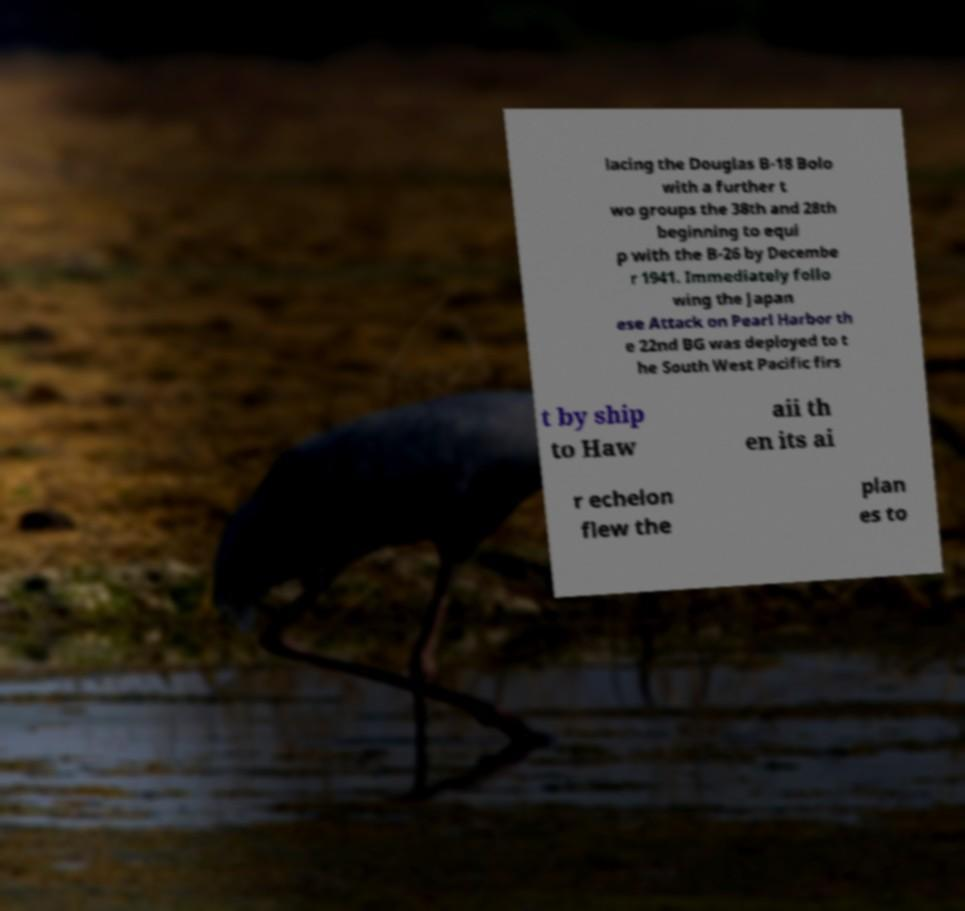Could you extract and type out the text from this image? lacing the Douglas B-18 Bolo with a further t wo groups the 38th and 28th beginning to equi p with the B-26 by Decembe r 1941. Immediately follo wing the Japan ese Attack on Pearl Harbor th e 22nd BG was deployed to t he South West Pacific firs t by ship to Haw aii th en its ai r echelon flew the plan es to 